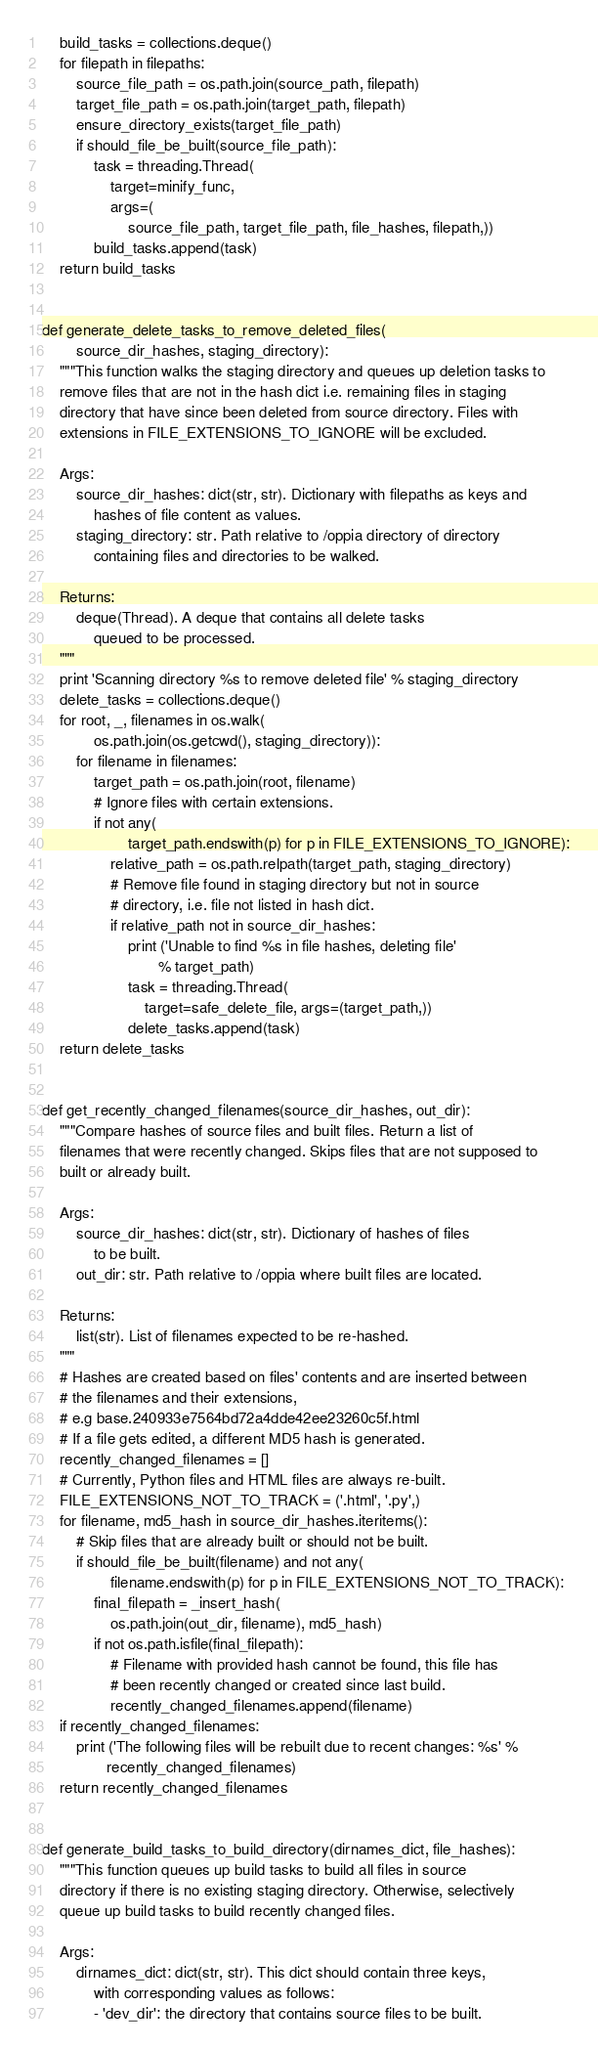Convert code to text. <code><loc_0><loc_0><loc_500><loc_500><_Python_>    build_tasks = collections.deque()
    for filepath in filepaths:
        source_file_path = os.path.join(source_path, filepath)
        target_file_path = os.path.join(target_path, filepath)
        ensure_directory_exists(target_file_path)
        if should_file_be_built(source_file_path):
            task = threading.Thread(
                target=minify_func,
                args=(
                    source_file_path, target_file_path, file_hashes, filepath,))
            build_tasks.append(task)
    return build_tasks


def generate_delete_tasks_to_remove_deleted_files(
        source_dir_hashes, staging_directory):
    """This function walks the staging directory and queues up deletion tasks to
    remove files that are not in the hash dict i.e. remaining files in staging
    directory that have since been deleted from source directory. Files with
    extensions in FILE_EXTENSIONS_TO_IGNORE will be excluded.

    Args:
        source_dir_hashes: dict(str, str). Dictionary with filepaths as keys and
            hashes of file content as values.
        staging_directory: str. Path relative to /oppia directory of directory
            containing files and directories to be walked.

    Returns:
        deque(Thread). A deque that contains all delete tasks
            queued to be processed.
    """
    print 'Scanning directory %s to remove deleted file' % staging_directory
    delete_tasks = collections.deque()
    for root, _, filenames in os.walk(
            os.path.join(os.getcwd(), staging_directory)):
        for filename in filenames:
            target_path = os.path.join(root, filename)
            # Ignore files with certain extensions.
            if not any(
                    target_path.endswith(p) for p in FILE_EXTENSIONS_TO_IGNORE):
                relative_path = os.path.relpath(target_path, staging_directory)
                # Remove file found in staging directory but not in source
                # directory, i.e. file not listed in hash dict.
                if relative_path not in source_dir_hashes:
                    print ('Unable to find %s in file hashes, deleting file'
                           % target_path)
                    task = threading.Thread(
                        target=safe_delete_file, args=(target_path,))
                    delete_tasks.append(task)
    return delete_tasks


def get_recently_changed_filenames(source_dir_hashes, out_dir):
    """Compare hashes of source files and built files. Return a list of
    filenames that were recently changed. Skips files that are not supposed to
    built or already built.

    Args:
        source_dir_hashes: dict(str, str). Dictionary of hashes of files
            to be built.
        out_dir: str. Path relative to /oppia where built files are located.

    Returns:
        list(str). List of filenames expected to be re-hashed.
    """
    # Hashes are created based on files' contents and are inserted between
    # the filenames and their extensions,
    # e.g base.240933e7564bd72a4dde42ee23260c5f.html
    # If a file gets edited, a different MD5 hash is generated.
    recently_changed_filenames = []
    # Currently, Python files and HTML files are always re-built.
    FILE_EXTENSIONS_NOT_TO_TRACK = ('.html', '.py',)
    for filename, md5_hash in source_dir_hashes.iteritems():
        # Skip files that are already built or should not be built.
        if should_file_be_built(filename) and not any(
                filename.endswith(p) for p in FILE_EXTENSIONS_NOT_TO_TRACK):
            final_filepath = _insert_hash(
                os.path.join(out_dir, filename), md5_hash)
            if not os.path.isfile(final_filepath):
                # Filename with provided hash cannot be found, this file has
                # been recently changed or created since last build.
                recently_changed_filenames.append(filename)
    if recently_changed_filenames:
        print ('The following files will be rebuilt due to recent changes: %s' %
               recently_changed_filenames)
    return recently_changed_filenames


def generate_build_tasks_to_build_directory(dirnames_dict, file_hashes):
    """This function queues up build tasks to build all files in source
    directory if there is no existing staging directory. Otherwise, selectively
    queue up build tasks to build recently changed files.

    Args:
        dirnames_dict: dict(str, str). This dict should contain three keys,
            with corresponding values as follows:
            - 'dev_dir': the directory that contains source files to be built.</code> 